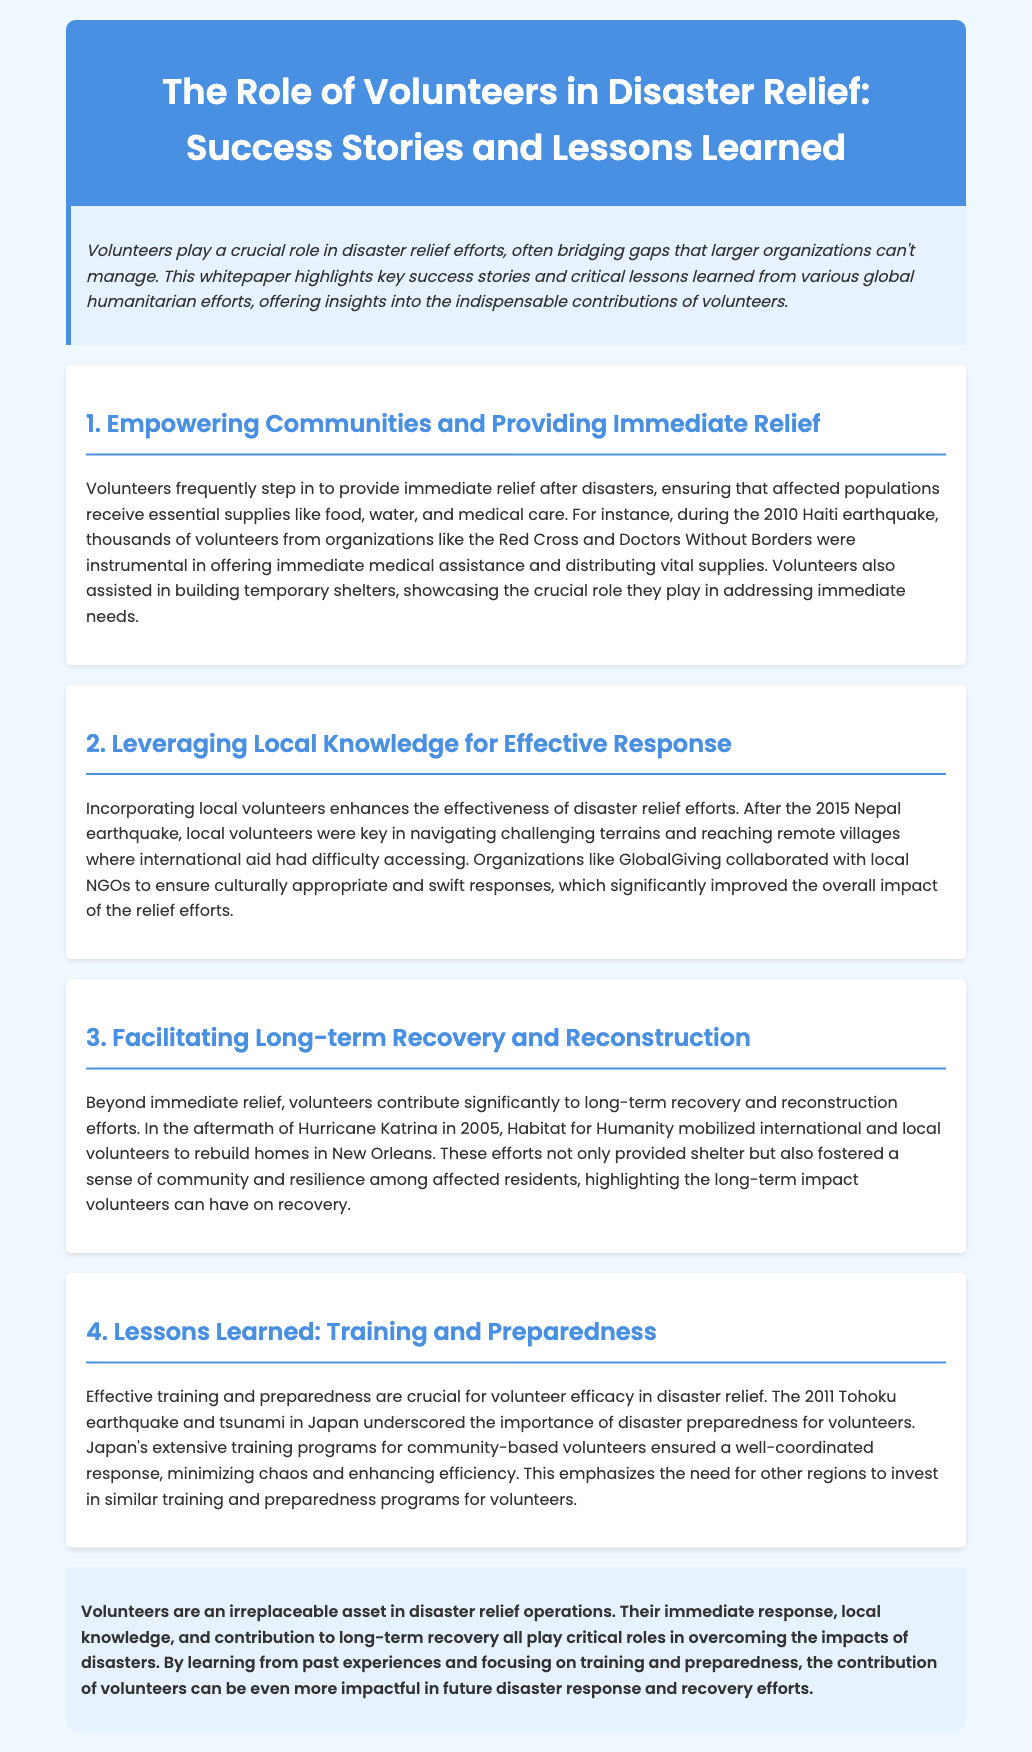What was the year of the Haiti earthquake mentioned? The document mentions the year of the Haiti earthquake as 2010.
Answer: 2010 Which organization collaborated with local NGOs after the Nepal earthquake? The document states that GlobalGiving collaborated with local NGOs following the Nepal earthquake.
Answer: GlobalGiving What type of homes were rebuilt by Habitat for Humanity in New Orleans? The document specifies that Habitat for Humanity mobilized volunteers to rebuild homes in New Orleans after Hurricane Katrina.
Answer: Homes What critical necessity did volunteers provide after the 2010 Haiti earthquake? The document highlights that volunteers provided essential supplies like food, water, and medical care after the Haiti earthquake.
Answer: Food, water, and medical care What key lesson was emphasized following the Tohoku earthquake and tsunami in Japan? The document points out that Japan's extensive training programs for community-based volunteers highlighted the importance of disaster preparedness.
Answer: Disaster preparedness How did local volunteers impact the response to the Nepal earthquake? The document states local volunteers enhanced the effectiveness of disaster relief efforts by navigating challenging terrains.
Answer: Navigating challenging terrains What type of document is this text? The content of the document indicates it is a whitepaper discussing the role of volunteers in disaster relief.
Answer: Whitepaper What crucial function do volunteers serve in disaster relief efforts? The document emphasizes that volunteers are crucial in providing immediate relief, local knowledge, and long-term recovery.
Answer: Immediate relief, local knowledge, and long-term recovery 